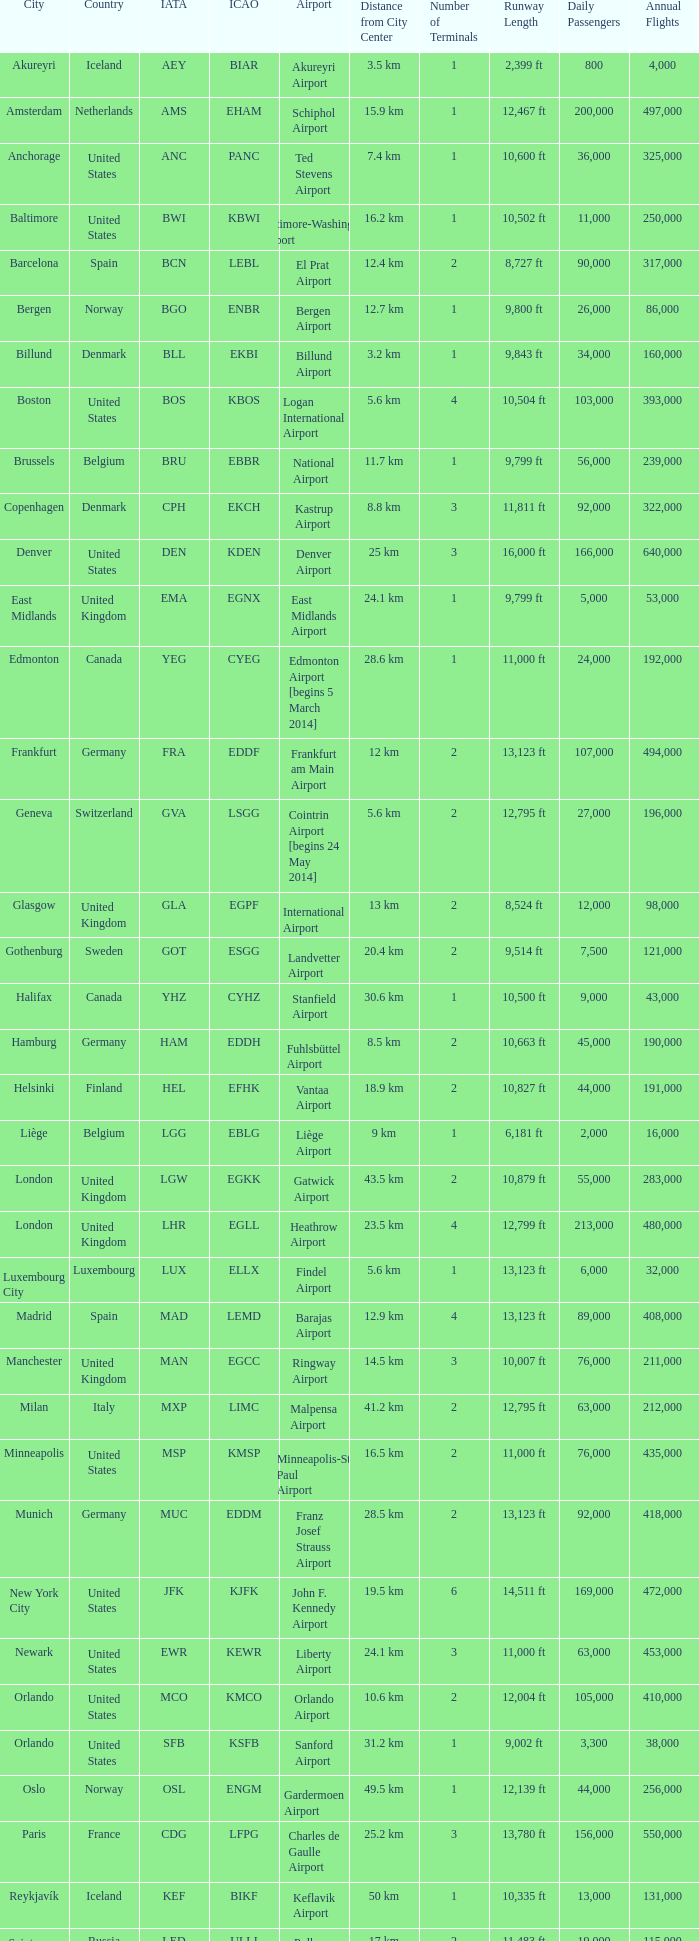Which airport has the iata code sea? Seattle–Tacoma Airport. 